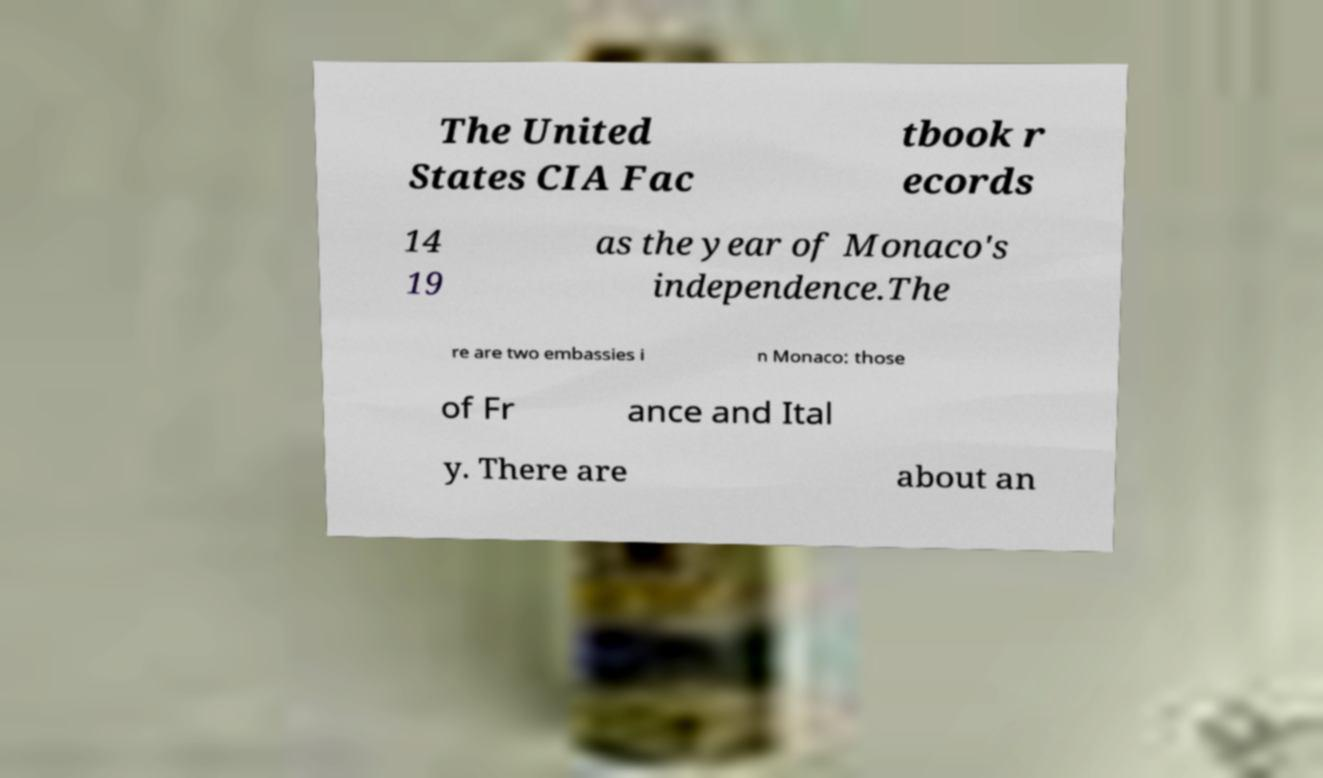Could you extract and type out the text from this image? The United States CIA Fac tbook r ecords 14 19 as the year of Monaco's independence.The re are two embassies i n Monaco: those of Fr ance and Ital y. There are about an 